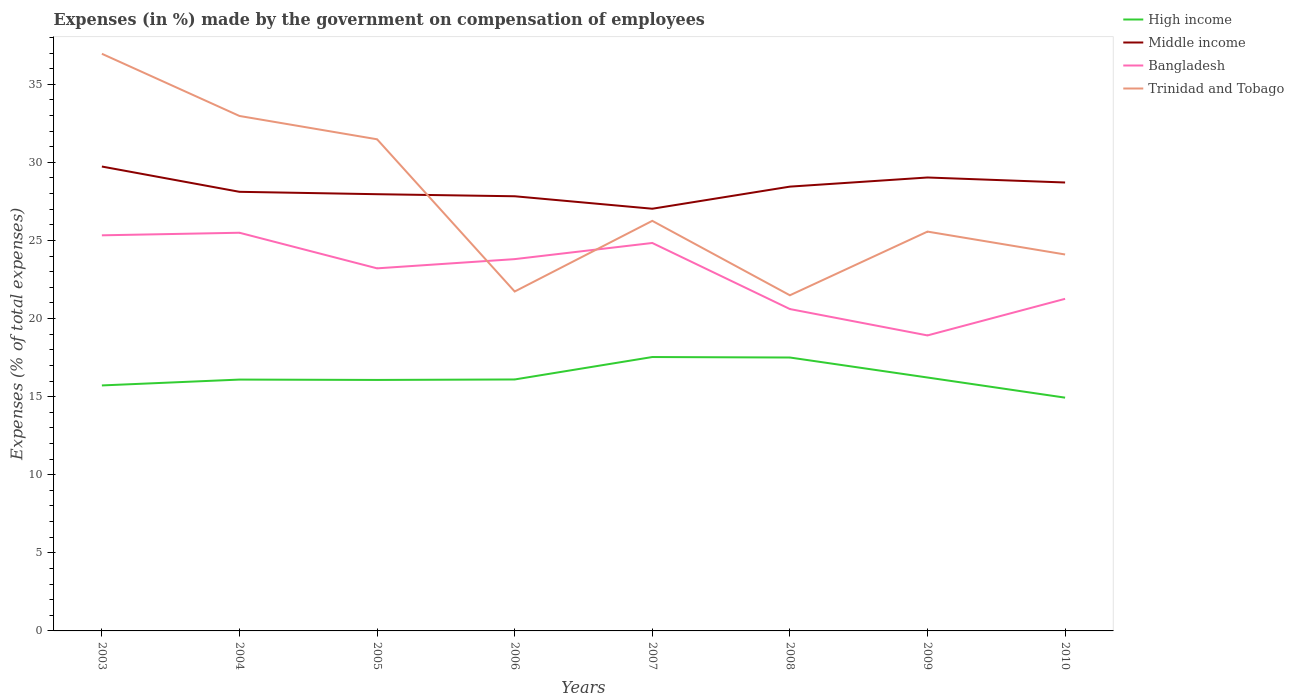Does the line corresponding to High income intersect with the line corresponding to Middle income?
Your answer should be very brief. No. Is the number of lines equal to the number of legend labels?
Ensure brevity in your answer.  Yes. Across all years, what is the maximum percentage of expenses made by the government on compensation of employees in Bangladesh?
Your response must be concise. 18.92. In which year was the percentage of expenses made by the government on compensation of employees in Middle income maximum?
Provide a short and direct response. 2007. What is the total percentage of expenses made by the government on compensation of employees in Bangladesh in the graph?
Offer a very short reply. 3.58. What is the difference between the highest and the second highest percentage of expenses made by the government on compensation of employees in Bangladesh?
Ensure brevity in your answer.  6.57. What is the difference between the highest and the lowest percentage of expenses made by the government on compensation of employees in Trinidad and Tobago?
Offer a very short reply. 3. Is the percentage of expenses made by the government on compensation of employees in Bangladesh strictly greater than the percentage of expenses made by the government on compensation of employees in Middle income over the years?
Your response must be concise. Yes. How many years are there in the graph?
Your answer should be compact. 8. Where does the legend appear in the graph?
Offer a very short reply. Top right. How are the legend labels stacked?
Offer a very short reply. Vertical. What is the title of the graph?
Provide a short and direct response. Expenses (in %) made by the government on compensation of employees. What is the label or title of the Y-axis?
Your answer should be very brief. Expenses (% of total expenses). What is the Expenses (% of total expenses) of High income in 2003?
Ensure brevity in your answer.  15.72. What is the Expenses (% of total expenses) of Middle income in 2003?
Keep it short and to the point. 29.73. What is the Expenses (% of total expenses) of Bangladesh in 2003?
Your response must be concise. 25.33. What is the Expenses (% of total expenses) in Trinidad and Tobago in 2003?
Keep it short and to the point. 36.95. What is the Expenses (% of total expenses) in High income in 2004?
Provide a succinct answer. 16.09. What is the Expenses (% of total expenses) in Middle income in 2004?
Your answer should be very brief. 28.12. What is the Expenses (% of total expenses) of Bangladesh in 2004?
Make the answer very short. 25.49. What is the Expenses (% of total expenses) in Trinidad and Tobago in 2004?
Offer a very short reply. 32.97. What is the Expenses (% of total expenses) in High income in 2005?
Keep it short and to the point. 16.07. What is the Expenses (% of total expenses) in Middle income in 2005?
Provide a succinct answer. 27.96. What is the Expenses (% of total expenses) of Bangladesh in 2005?
Ensure brevity in your answer.  23.21. What is the Expenses (% of total expenses) in Trinidad and Tobago in 2005?
Give a very brief answer. 31.48. What is the Expenses (% of total expenses) of High income in 2006?
Offer a very short reply. 16.1. What is the Expenses (% of total expenses) in Middle income in 2006?
Offer a terse response. 27.83. What is the Expenses (% of total expenses) of Bangladesh in 2006?
Provide a short and direct response. 23.81. What is the Expenses (% of total expenses) of Trinidad and Tobago in 2006?
Provide a succinct answer. 21.73. What is the Expenses (% of total expenses) in High income in 2007?
Your response must be concise. 17.54. What is the Expenses (% of total expenses) in Middle income in 2007?
Your response must be concise. 27.03. What is the Expenses (% of total expenses) of Bangladesh in 2007?
Ensure brevity in your answer.  24.84. What is the Expenses (% of total expenses) in Trinidad and Tobago in 2007?
Your answer should be very brief. 26.26. What is the Expenses (% of total expenses) of High income in 2008?
Keep it short and to the point. 17.51. What is the Expenses (% of total expenses) of Middle income in 2008?
Give a very brief answer. 28.45. What is the Expenses (% of total expenses) of Bangladesh in 2008?
Ensure brevity in your answer.  20.61. What is the Expenses (% of total expenses) in Trinidad and Tobago in 2008?
Keep it short and to the point. 21.49. What is the Expenses (% of total expenses) in High income in 2009?
Keep it short and to the point. 16.23. What is the Expenses (% of total expenses) in Middle income in 2009?
Ensure brevity in your answer.  29.03. What is the Expenses (% of total expenses) in Bangladesh in 2009?
Offer a very short reply. 18.92. What is the Expenses (% of total expenses) in Trinidad and Tobago in 2009?
Ensure brevity in your answer.  25.57. What is the Expenses (% of total expenses) in High income in 2010?
Your answer should be compact. 14.94. What is the Expenses (% of total expenses) of Middle income in 2010?
Your response must be concise. 28.71. What is the Expenses (% of total expenses) of Bangladesh in 2010?
Keep it short and to the point. 21.26. What is the Expenses (% of total expenses) in Trinidad and Tobago in 2010?
Make the answer very short. 24.1. Across all years, what is the maximum Expenses (% of total expenses) of High income?
Offer a terse response. 17.54. Across all years, what is the maximum Expenses (% of total expenses) of Middle income?
Your answer should be very brief. 29.73. Across all years, what is the maximum Expenses (% of total expenses) of Bangladesh?
Provide a short and direct response. 25.49. Across all years, what is the maximum Expenses (% of total expenses) in Trinidad and Tobago?
Offer a terse response. 36.95. Across all years, what is the minimum Expenses (% of total expenses) in High income?
Keep it short and to the point. 14.94. Across all years, what is the minimum Expenses (% of total expenses) of Middle income?
Your response must be concise. 27.03. Across all years, what is the minimum Expenses (% of total expenses) of Bangladesh?
Ensure brevity in your answer.  18.92. Across all years, what is the minimum Expenses (% of total expenses) of Trinidad and Tobago?
Give a very brief answer. 21.49. What is the total Expenses (% of total expenses) of High income in the graph?
Offer a very short reply. 130.18. What is the total Expenses (% of total expenses) in Middle income in the graph?
Provide a succinct answer. 226.86. What is the total Expenses (% of total expenses) in Bangladesh in the graph?
Make the answer very short. 183.47. What is the total Expenses (% of total expenses) in Trinidad and Tobago in the graph?
Ensure brevity in your answer.  220.55. What is the difference between the Expenses (% of total expenses) in High income in 2003 and that in 2004?
Your answer should be very brief. -0.37. What is the difference between the Expenses (% of total expenses) of Middle income in 2003 and that in 2004?
Give a very brief answer. 1.62. What is the difference between the Expenses (% of total expenses) of Bangladesh in 2003 and that in 2004?
Offer a terse response. -0.16. What is the difference between the Expenses (% of total expenses) in Trinidad and Tobago in 2003 and that in 2004?
Offer a very short reply. 3.98. What is the difference between the Expenses (% of total expenses) in High income in 2003 and that in 2005?
Your answer should be compact. -0.35. What is the difference between the Expenses (% of total expenses) of Middle income in 2003 and that in 2005?
Your answer should be compact. 1.77. What is the difference between the Expenses (% of total expenses) in Bangladesh in 2003 and that in 2005?
Offer a terse response. 2.12. What is the difference between the Expenses (% of total expenses) in Trinidad and Tobago in 2003 and that in 2005?
Make the answer very short. 5.48. What is the difference between the Expenses (% of total expenses) in High income in 2003 and that in 2006?
Ensure brevity in your answer.  -0.38. What is the difference between the Expenses (% of total expenses) of Middle income in 2003 and that in 2006?
Ensure brevity in your answer.  1.9. What is the difference between the Expenses (% of total expenses) in Bangladesh in 2003 and that in 2006?
Your answer should be compact. 1.52. What is the difference between the Expenses (% of total expenses) in Trinidad and Tobago in 2003 and that in 2006?
Offer a very short reply. 15.22. What is the difference between the Expenses (% of total expenses) in High income in 2003 and that in 2007?
Your response must be concise. -1.82. What is the difference between the Expenses (% of total expenses) in Middle income in 2003 and that in 2007?
Give a very brief answer. 2.7. What is the difference between the Expenses (% of total expenses) in Bangladesh in 2003 and that in 2007?
Make the answer very short. 0.49. What is the difference between the Expenses (% of total expenses) of Trinidad and Tobago in 2003 and that in 2007?
Your answer should be very brief. 10.7. What is the difference between the Expenses (% of total expenses) of High income in 2003 and that in 2008?
Your response must be concise. -1.79. What is the difference between the Expenses (% of total expenses) in Middle income in 2003 and that in 2008?
Give a very brief answer. 1.29. What is the difference between the Expenses (% of total expenses) of Bangladesh in 2003 and that in 2008?
Your response must be concise. 4.72. What is the difference between the Expenses (% of total expenses) in Trinidad and Tobago in 2003 and that in 2008?
Provide a short and direct response. 15.46. What is the difference between the Expenses (% of total expenses) of High income in 2003 and that in 2009?
Provide a short and direct response. -0.51. What is the difference between the Expenses (% of total expenses) of Middle income in 2003 and that in 2009?
Offer a terse response. 0.7. What is the difference between the Expenses (% of total expenses) in Bangladesh in 2003 and that in 2009?
Your answer should be compact. 6.41. What is the difference between the Expenses (% of total expenses) in Trinidad and Tobago in 2003 and that in 2009?
Your answer should be compact. 11.39. What is the difference between the Expenses (% of total expenses) in High income in 2003 and that in 2010?
Your answer should be very brief. 0.78. What is the difference between the Expenses (% of total expenses) of Middle income in 2003 and that in 2010?
Provide a succinct answer. 1.02. What is the difference between the Expenses (% of total expenses) in Bangladesh in 2003 and that in 2010?
Make the answer very short. 4.07. What is the difference between the Expenses (% of total expenses) in Trinidad and Tobago in 2003 and that in 2010?
Your response must be concise. 12.85. What is the difference between the Expenses (% of total expenses) of High income in 2004 and that in 2005?
Your response must be concise. 0.02. What is the difference between the Expenses (% of total expenses) of Middle income in 2004 and that in 2005?
Make the answer very short. 0.15. What is the difference between the Expenses (% of total expenses) of Bangladesh in 2004 and that in 2005?
Your answer should be compact. 2.28. What is the difference between the Expenses (% of total expenses) of Trinidad and Tobago in 2004 and that in 2005?
Your response must be concise. 1.49. What is the difference between the Expenses (% of total expenses) in High income in 2004 and that in 2006?
Your answer should be very brief. -0.01. What is the difference between the Expenses (% of total expenses) in Middle income in 2004 and that in 2006?
Your response must be concise. 0.28. What is the difference between the Expenses (% of total expenses) of Bangladesh in 2004 and that in 2006?
Provide a short and direct response. 1.69. What is the difference between the Expenses (% of total expenses) of Trinidad and Tobago in 2004 and that in 2006?
Keep it short and to the point. 11.24. What is the difference between the Expenses (% of total expenses) of High income in 2004 and that in 2007?
Your answer should be compact. -1.44. What is the difference between the Expenses (% of total expenses) of Middle income in 2004 and that in 2007?
Provide a succinct answer. 1.08. What is the difference between the Expenses (% of total expenses) in Bangladesh in 2004 and that in 2007?
Offer a terse response. 0.66. What is the difference between the Expenses (% of total expenses) of Trinidad and Tobago in 2004 and that in 2007?
Your response must be concise. 6.71. What is the difference between the Expenses (% of total expenses) of High income in 2004 and that in 2008?
Ensure brevity in your answer.  -1.41. What is the difference between the Expenses (% of total expenses) of Middle income in 2004 and that in 2008?
Provide a succinct answer. -0.33. What is the difference between the Expenses (% of total expenses) in Bangladesh in 2004 and that in 2008?
Keep it short and to the point. 4.89. What is the difference between the Expenses (% of total expenses) in Trinidad and Tobago in 2004 and that in 2008?
Make the answer very short. 11.48. What is the difference between the Expenses (% of total expenses) of High income in 2004 and that in 2009?
Offer a terse response. -0.13. What is the difference between the Expenses (% of total expenses) of Middle income in 2004 and that in 2009?
Your response must be concise. -0.92. What is the difference between the Expenses (% of total expenses) in Bangladesh in 2004 and that in 2009?
Your answer should be very brief. 6.57. What is the difference between the Expenses (% of total expenses) of Trinidad and Tobago in 2004 and that in 2009?
Keep it short and to the point. 7.4. What is the difference between the Expenses (% of total expenses) of High income in 2004 and that in 2010?
Offer a very short reply. 1.16. What is the difference between the Expenses (% of total expenses) of Middle income in 2004 and that in 2010?
Make the answer very short. -0.6. What is the difference between the Expenses (% of total expenses) of Bangladesh in 2004 and that in 2010?
Give a very brief answer. 4.23. What is the difference between the Expenses (% of total expenses) in Trinidad and Tobago in 2004 and that in 2010?
Provide a succinct answer. 8.87. What is the difference between the Expenses (% of total expenses) in High income in 2005 and that in 2006?
Provide a succinct answer. -0.03. What is the difference between the Expenses (% of total expenses) in Middle income in 2005 and that in 2006?
Your answer should be compact. 0.13. What is the difference between the Expenses (% of total expenses) in Bangladesh in 2005 and that in 2006?
Provide a succinct answer. -0.59. What is the difference between the Expenses (% of total expenses) of Trinidad and Tobago in 2005 and that in 2006?
Give a very brief answer. 9.75. What is the difference between the Expenses (% of total expenses) in High income in 2005 and that in 2007?
Your response must be concise. -1.47. What is the difference between the Expenses (% of total expenses) in Middle income in 2005 and that in 2007?
Offer a very short reply. 0.93. What is the difference between the Expenses (% of total expenses) of Bangladesh in 2005 and that in 2007?
Provide a short and direct response. -1.62. What is the difference between the Expenses (% of total expenses) of Trinidad and Tobago in 2005 and that in 2007?
Make the answer very short. 5.22. What is the difference between the Expenses (% of total expenses) of High income in 2005 and that in 2008?
Provide a short and direct response. -1.44. What is the difference between the Expenses (% of total expenses) of Middle income in 2005 and that in 2008?
Your response must be concise. -0.49. What is the difference between the Expenses (% of total expenses) of Bangladesh in 2005 and that in 2008?
Offer a very short reply. 2.61. What is the difference between the Expenses (% of total expenses) of Trinidad and Tobago in 2005 and that in 2008?
Provide a short and direct response. 9.99. What is the difference between the Expenses (% of total expenses) of High income in 2005 and that in 2009?
Your answer should be very brief. -0.16. What is the difference between the Expenses (% of total expenses) in Middle income in 2005 and that in 2009?
Offer a terse response. -1.07. What is the difference between the Expenses (% of total expenses) of Bangladesh in 2005 and that in 2009?
Give a very brief answer. 4.29. What is the difference between the Expenses (% of total expenses) in Trinidad and Tobago in 2005 and that in 2009?
Offer a very short reply. 5.91. What is the difference between the Expenses (% of total expenses) in High income in 2005 and that in 2010?
Your answer should be compact. 1.13. What is the difference between the Expenses (% of total expenses) in Middle income in 2005 and that in 2010?
Offer a terse response. -0.75. What is the difference between the Expenses (% of total expenses) in Bangladesh in 2005 and that in 2010?
Your answer should be compact. 1.95. What is the difference between the Expenses (% of total expenses) of Trinidad and Tobago in 2005 and that in 2010?
Your answer should be very brief. 7.38. What is the difference between the Expenses (% of total expenses) of High income in 2006 and that in 2007?
Your answer should be compact. -1.44. What is the difference between the Expenses (% of total expenses) in Middle income in 2006 and that in 2007?
Offer a terse response. 0.8. What is the difference between the Expenses (% of total expenses) of Bangladesh in 2006 and that in 2007?
Give a very brief answer. -1.03. What is the difference between the Expenses (% of total expenses) in Trinidad and Tobago in 2006 and that in 2007?
Provide a short and direct response. -4.53. What is the difference between the Expenses (% of total expenses) in High income in 2006 and that in 2008?
Your response must be concise. -1.41. What is the difference between the Expenses (% of total expenses) in Middle income in 2006 and that in 2008?
Ensure brevity in your answer.  -0.62. What is the difference between the Expenses (% of total expenses) in Bangladesh in 2006 and that in 2008?
Keep it short and to the point. 3.2. What is the difference between the Expenses (% of total expenses) of Trinidad and Tobago in 2006 and that in 2008?
Offer a terse response. 0.24. What is the difference between the Expenses (% of total expenses) of High income in 2006 and that in 2009?
Give a very brief answer. -0.12. What is the difference between the Expenses (% of total expenses) of Middle income in 2006 and that in 2009?
Offer a terse response. -1.2. What is the difference between the Expenses (% of total expenses) in Bangladesh in 2006 and that in 2009?
Ensure brevity in your answer.  4.89. What is the difference between the Expenses (% of total expenses) of Trinidad and Tobago in 2006 and that in 2009?
Make the answer very short. -3.84. What is the difference between the Expenses (% of total expenses) in High income in 2006 and that in 2010?
Ensure brevity in your answer.  1.16. What is the difference between the Expenses (% of total expenses) in Middle income in 2006 and that in 2010?
Keep it short and to the point. -0.88. What is the difference between the Expenses (% of total expenses) of Bangladesh in 2006 and that in 2010?
Your answer should be very brief. 2.54. What is the difference between the Expenses (% of total expenses) in Trinidad and Tobago in 2006 and that in 2010?
Offer a terse response. -2.37. What is the difference between the Expenses (% of total expenses) in High income in 2007 and that in 2008?
Ensure brevity in your answer.  0.03. What is the difference between the Expenses (% of total expenses) in Middle income in 2007 and that in 2008?
Ensure brevity in your answer.  -1.42. What is the difference between the Expenses (% of total expenses) of Bangladesh in 2007 and that in 2008?
Provide a succinct answer. 4.23. What is the difference between the Expenses (% of total expenses) of Trinidad and Tobago in 2007 and that in 2008?
Offer a terse response. 4.77. What is the difference between the Expenses (% of total expenses) in High income in 2007 and that in 2009?
Keep it short and to the point. 1.31. What is the difference between the Expenses (% of total expenses) of Middle income in 2007 and that in 2009?
Ensure brevity in your answer.  -2. What is the difference between the Expenses (% of total expenses) in Bangladesh in 2007 and that in 2009?
Your response must be concise. 5.92. What is the difference between the Expenses (% of total expenses) in Trinidad and Tobago in 2007 and that in 2009?
Your answer should be compact. 0.69. What is the difference between the Expenses (% of total expenses) of High income in 2007 and that in 2010?
Provide a succinct answer. 2.6. What is the difference between the Expenses (% of total expenses) in Middle income in 2007 and that in 2010?
Your answer should be compact. -1.68. What is the difference between the Expenses (% of total expenses) of Bangladesh in 2007 and that in 2010?
Your response must be concise. 3.58. What is the difference between the Expenses (% of total expenses) of Trinidad and Tobago in 2007 and that in 2010?
Ensure brevity in your answer.  2.15. What is the difference between the Expenses (% of total expenses) in High income in 2008 and that in 2009?
Make the answer very short. 1.28. What is the difference between the Expenses (% of total expenses) of Middle income in 2008 and that in 2009?
Offer a terse response. -0.58. What is the difference between the Expenses (% of total expenses) of Bangladesh in 2008 and that in 2009?
Your answer should be compact. 1.69. What is the difference between the Expenses (% of total expenses) in Trinidad and Tobago in 2008 and that in 2009?
Keep it short and to the point. -4.08. What is the difference between the Expenses (% of total expenses) of High income in 2008 and that in 2010?
Offer a terse response. 2.57. What is the difference between the Expenses (% of total expenses) of Middle income in 2008 and that in 2010?
Make the answer very short. -0.26. What is the difference between the Expenses (% of total expenses) in Bangladesh in 2008 and that in 2010?
Offer a terse response. -0.66. What is the difference between the Expenses (% of total expenses) in Trinidad and Tobago in 2008 and that in 2010?
Your response must be concise. -2.61. What is the difference between the Expenses (% of total expenses) in High income in 2009 and that in 2010?
Provide a succinct answer. 1.29. What is the difference between the Expenses (% of total expenses) in Middle income in 2009 and that in 2010?
Give a very brief answer. 0.32. What is the difference between the Expenses (% of total expenses) of Bangladesh in 2009 and that in 2010?
Your response must be concise. -2.34. What is the difference between the Expenses (% of total expenses) in Trinidad and Tobago in 2009 and that in 2010?
Your answer should be compact. 1.47. What is the difference between the Expenses (% of total expenses) of High income in 2003 and the Expenses (% of total expenses) of Middle income in 2004?
Your answer should be compact. -12.4. What is the difference between the Expenses (% of total expenses) of High income in 2003 and the Expenses (% of total expenses) of Bangladesh in 2004?
Offer a terse response. -9.78. What is the difference between the Expenses (% of total expenses) of High income in 2003 and the Expenses (% of total expenses) of Trinidad and Tobago in 2004?
Offer a very short reply. -17.25. What is the difference between the Expenses (% of total expenses) of Middle income in 2003 and the Expenses (% of total expenses) of Bangladesh in 2004?
Offer a terse response. 4.24. What is the difference between the Expenses (% of total expenses) in Middle income in 2003 and the Expenses (% of total expenses) in Trinidad and Tobago in 2004?
Provide a succinct answer. -3.24. What is the difference between the Expenses (% of total expenses) in Bangladesh in 2003 and the Expenses (% of total expenses) in Trinidad and Tobago in 2004?
Offer a terse response. -7.64. What is the difference between the Expenses (% of total expenses) of High income in 2003 and the Expenses (% of total expenses) of Middle income in 2005?
Give a very brief answer. -12.24. What is the difference between the Expenses (% of total expenses) in High income in 2003 and the Expenses (% of total expenses) in Bangladesh in 2005?
Provide a short and direct response. -7.5. What is the difference between the Expenses (% of total expenses) in High income in 2003 and the Expenses (% of total expenses) in Trinidad and Tobago in 2005?
Ensure brevity in your answer.  -15.76. What is the difference between the Expenses (% of total expenses) in Middle income in 2003 and the Expenses (% of total expenses) in Bangladesh in 2005?
Provide a succinct answer. 6.52. What is the difference between the Expenses (% of total expenses) of Middle income in 2003 and the Expenses (% of total expenses) of Trinidad and Tobago in 2005?
Ensure brevity in your answer.  -1.74. What is the difference between the Expenses (% of total expenses) of Bangladesh in 2003 and the Expenses (% of total expenses) of Trinidad and Tobago in 2005?
Provide a short and direct response. -6.15. What is the difference between the Expenses (% of total expenses) in High income in 2003 and the Expenses (% of total expenses) in Middle income in 2006?
Ensure brevity in your answer.  -12.11. What is the difference between the Expenses (% of total expenses) of High income in 2003 and the Expenses (% of total expenses) of Bangladesh in 2006?
Your response must be concise. -8.09. What is the difference between the Expenses (% of total expenses) of High income in 2003 and the Expenses (% of total expenses) of Trinidad and Tobago in 2006?
Give a very brief answer. -6.01. What is the difference between the Expenses (% of total expenses) in Middle income in 2003 and the Expenses (% of total expenses) in Bangladesh in 2006?
Ensure brevity in your answer.  5.93. What is the difference between the Expenses (% of total expenses) of Middle income in 2003 and the Expenses (% of total expenses) of Trinidad and Tobago in 2006?
Provide a succinct answer. 8. What is the difference between the Expenses (% of total expenses) of Bangladesh in 2003 and the Expenses (% of total expenses) of Trinidad and Tobago in 2006?
Your answer should be very brief. 3.6. What is the difference between the Expenses (% of total expenses) of High income in 2003 and the Expenses (% of total expenses) of Middle income in 2007?
Your answer should be compact. -11.31. What is the difference between the Expenses (% of total expenses) in High income in 2003 and the Expenses (% of total expenses) in Bangladesh in 2007?
Make the answer very short. -9.12. What is the difference between the Expenses (% of total expenses) in High income in 2003 and the Expenses (% of total expenses) in Trinidad and Tobago in 2007?
Offer a terse response. -10.54. What is the difference between the Expenses (% of total expenses) in Middle income in 2003 and the Expenses (% of total expenses) in Bangladesh in 2007?
Make the answer very short. 4.89. What is the difference between the Expenses (% of total expenses) in Middle income in 2003 and the Expenses (% of total expenses) in Trinidad and Tobago in 2007?
Keep it short and to the point. 3.48. What is the difference between the Expenses (% of total expenses) in Bangladesh in 2003 and the Expenses (% of total expenses) in Trinidad and Tobago in 2007?
Give a very brief answer. -0.93. What is the difference between the Expenses (% of total expenses) of High income in 2003 and the Expenses (% of total expenses) of Middle income in 2008?
Provide a succinct answer. -12.73. What is the difference between the Expenses (% of total expenses) of High income in 2003 and the Expenses (% of total expenses) of Bangladesh in 2008?
Give a very brief answer. -4.89. What is the difference between the Expenses (% of total expenses) in High income in 2003 and the Expenses (% of total expenses) in Trinidad and Tobago in 2008?
Provide a short and direct response. -5.77. What is the difference between the Expenses (% of total expenses) of Middle income in 2003 and the Expenses (% of total expenses) of Bangladesh in 2008?
Your answer should be very brief. 9.13. What is the difference between the Expenses (% of total expenses) in Middle income in 2003 and the Expenses (% of total expenses) in Trinidad and Tobago in 2008?
Make the answer very short. 8.24. What is the difference between the Expenses (% of total expenses) of Bangladesh in 2003 and the Expenses (% of total expenses) of Trinidad and Tobago in 2008?
Offer a terse response. 3.84. What is the difference between the Expenses (% of total expenses) in High income in 2003 and the Expenses (% of total expenses) in Middle income in 2009?
Ensure brevity in your answer.  -13.31. What is the difference between the Expenses (% of total expenses) in High income in 2003 and the Expenses (% of total expenses) in Bangladesh in 2009?
Your response must be concise. -3.2. What is the difference between the Expenses (% of total expenses) of High income in 2003 and the Expenses (% of total expenses) of Trinidad and Tobago in 2009?
Make the answer very short. -9.85. What is the difference between the Expenses (% of total expenses) of Middle income in 2003 and the Expenses (% of total expenses) of Bangladesh in 2009?
Provide a succinct answer. 10.81. What is the difference between the Expenses (% of total expenses) of Middle income in 2003 and the Expenses (% of total expenses) of Trinidad and Tobago in 2009?
Give a very brief answer. 4.17. What is the difference between the Expenses (% of total expenses) in Bangladesh in 2003 and the Expenses (% of total expenses) in Trinidad and Tobago in 2009?
Provide a succinct answer. -0.24. What is the difference between the Expenses (% of total expenses) in High income in 2003 and the Expenses (% of total expenses) in Middle income in 2010?
Your answer should be very brief. -12.99. What is the difference between the Expenses (% of total expenses) in High income in 2003 and the Expenses (% of total expenses) in Bangladesh in 2010?
Offer a terse response. -5.55. What is the difference between the Expenses (% of total expenses) of High income in 2003 and the Expenses (% of total expenses) of Trinidad and Tobago in 2010?
Offer a terse response. -8.38. What is the difference between the Expenses (% of total expenses) in Middle income in 2003 and the Expenses (% of total expenses) in Bangladesh in 2010?
Your response must be concise. 8.47. What is the difference between the Expenses (% of total expenses) of Middle income in 2003 and the Expenses (% of total expenses) of Trinidad and Tobago in 2010?
Offer a terse response. 5.63. What is the difference between the Expenses (% of total expenses) of Bangladesh in 2003 and the Expenses (% of total expenses) of Trinidad and Tobago in 2010?
Your response must be concise. 1.23. What is the difference between the Expenses (% of total expenses) of High income in 2004 and the Expenses (% of total expenses) of Middle income in 2005?
Your response must be concise. -11.87. What is the difference between the Expenses (% of total expenses) in High income in 2004 and the Expenses (% of total expenses) in Bangladesh in 2005?
Make the answer very short. -7.12. What is the difference between the Expenses (% of total expenses) in High income in 2004 and the Expenses (% of total expenses) in Trinidad and Tobago in 2005?
Make the answer very short. -15.39. What is the difference between the Expenses (% of total expenses) in Middle income in 2004 and the Expenses (% of total expenses) in Bangladesh in 2005?
Offer a very short reply. 4.9. What is the difference between the Expenses (% of total expenses) in Middle income in 2004 and the Expenses (% of total expenses) in Trinidad and Tobago in 2005?
Your response must be concise. -3.36. What is the difference between the Expenses (% of total expenses) of Bangladesh in 2004 and the Expenses (% of total expenses) of Trinidad and Tobago in 2005?
Your answer should be compact. -5.98. What is the difference between the Expenses (% of total expenses) of High income in 2004 and the Expenses (% of total expenses) of Middle income in 2006?
Offer a terse response. -11.74. What is the difference between the Expenses (% of total expenses) of High income in 2004 and the Expenses (% of total expenses) of Bangladesh in 2006?
Your answer should be compact. -7.71. What is the difference between the Expenses (% of total expenses) in High income in 2004 and the Expenses (% of total expenses) in Trinidad and Tobago in 2006?
Give a very brief answer. -5.64. What is the difference between the Expenses (% of total expenses) in Middle income in 2004 and the Expenses (% of total expenses) in Bangladesh in 2006?
Your answer should be very brief. 4.31. What is the difference between the Expenses (% of total expenses) in Middle income in 2004 and the Expenses (% of total expenses) in Trinidad and Tobago in 2006?
Keep it short and to the point. 6.38. What is the difference between the Expenses (% of total expenses) in Bangladesh in 2004 and the Expenses (% of total expenses) in Trinidad and Tobago in 2006?
Make the answer very short. 3.76. What is the difference between the Expenses (% of total expenses) in High income in 2004 and the Expenses (% of total expenses) in Middle income in 2007?
Make the answer very short. -10.94. What is the difference between the Expenses (% of total expenses) of High income in 2004 and the Expenses (% of total expenses) of Bangladesh in 2007?
Your answer should be very brief. -8.75. What is the difference between the Expenses (% of total expenses) of High income in 2004 and the Expenses (% of total expenses) of Trinidad and Tobago in 2007?
Provide a succinct answer. -10.16. What is the difference between the Expenses (% of total expenses) of Middle income in 2004 and the Expenses (% of total expenses) of Bangladesh in 2007?
Offer a very short reply. 3.28. What is the difference between the Expenses (% of total expenses) of Middle income in 2004 and the Expenses (% of total expenses) of Trinidad and Tobago in 2007?
Make the answer very short. 1.86. What is the difference between the Expenses (% of total expenses) in Bangladesh in 2004 and the Expenses (% of total expenses) in Trinidad and Tobago in 2007?
Keep it short and to the point. -0.76. What is the difference between the Expenses (% of total expenses) of High income in 2004 and the Expenses (% of total expenses) of Middle income in 2008?
Your answer should be very brief. -12.35. What is the difference between the Expenses (% of total expenses) in High income in 2004 and the Expenses (% of total expenses) in Bangladesh in 2008?
Give a very brief answer. -4.52. What is the difference between the Expenses (% of total expenses) of High income in 2004 and the Expenses (% of total expenses) of Trinidad and Tobago in 2008?
Provide a succinct answer. -5.4. What is the difference between the Expenses (% of total expenses) in Middle income in 2004 and the Expenses (% of total expenses) in Bangladesh in 2008?
Provide a short and direct response. 7.51. What is the difference between the Expenses (% of total expenses) in Middle income in 2004 and the Expenses (% of total expenses) in Trinidad and Tobago in 2008?
Provide a short and direct response. 6.63. What is the difference between the Expenses (% of total expenses) in Bangladesh in 2004 and the Expenses (% of total expenses) in Trinidad and Tobago in 2008?
Your answer should be compact. 4. What is the difference between the Expenses (% of total expenses) in High income in 2004 and the Expenses (% of total expenses) in Middle income in 2009?
Your answer should be very brief. -12.94. What is the difference between the Expenses (% of total expenses) of High income in 2004 and the Expenses (% of total expenses) of Bangladesh in 2009?
Offer a terse response. -2.83. What is the difference between the Expenses (% of total expenses) of High income in 2004 and the Expenses (% of total expenses) of Trinidad and Tobago in 2009?
Make the answer very short. -9.47. What is the difference between the Expenses (% of total expenses) of Middle income in 2004 and the Expenses (% of total expenses) of Bangladesh in 2009?
Keep it short and to the point. 9.2. What is the difference between the Expenses (% of total expenses) in Middle income in 2004 and the Expenses (% of total expenses) in Trinidad and Tobago in 2009?
Your response must be concise. 2.55. What is the difference between the Expenses (% of total expenses) of Bangladesh in 2004 and the Expenses (% of total expenses) of Trinidad and Tobago in 2009?
Ensure brevity in your answer.  -0.07. What is the difference between the Expenses (% of total expenses) in High income in 2004 and the Expenses (% of total expenses) in Middle income in 2010?
Your answer should be compact. -12.62. What is the difference between the Expenses (% of total expenses) of High income in 2004 and the Expenses (% of total expenses) of Bangladesh in 2010?
Your response must be concise. -5.17. What is the difference between the Expenses (% of total expenses) of High income in 2004 and the Expenses (% of total expenses) of Trinidad and Tobago in 2010?
Provide a succinct answer. -8.01. What is the difference between the Expenses (% of total expenses) in Middle income in 2004 and the Expenses (% of total expenses) in Bangladesh in 2010?
Your answer should be compact. 6.85. What is the difference between the Expenses (% of total expenses) in Middle income in 2004 and the Expenses (% of total expenses) in Trinidad and Tobago in 2010?
Your response must be concise. 4.01. What is the difference between the Expenses (% of total expenses) in Bangladesh in 2004 and the Expenses (% of total expenses) in Trinidad and Tobago in 2010?
Keep it short and to the point. 1.39. What is the difference between the Expenses (% of total expenses) in High income in 2005 and the Expenses (% of total expenses) in Middle income in 2006?
Make the answer very short. -11.76. What is the difference between the Expenses (% of total expenses) in High income in 2005 and the Expenses (% of total expenses) in Bangladesh in 2006?
Give a very brief answer. -7.74. What is the difference between the Expenses (% of total expenses) in High income in 2005 and the Expenses (% of total expenses) in Trinidad and Tobago in 2006?
Keep it short and to the point. -5.66. What is the difference between the Expenses (% of total expenses) in Middle income in 2005 and the Expenses (% of total expenses) in Bangladesh in 2006?
Keep it short and to the point. 4.16. What is the difference between the Expenses (% of total expenses) of Middle income in 2005 and the Expenses (% of total expenses) of Trinidad and Tobago in 2006?
Offer a very short reply. 6.23. What is the difference between the Expenses (% of total expenses) of Bangladesh in 2005 and the Expenses (% of total expenses) of Trinidad and Tobago in 2006?
Provide a short and direct response. 1.48. What is the difference between the Expenses (% of total expenses) in High income in 2005 and the Expenses (% of total expenses) in Middle income in 2007?
Give a very brief answer. -10.96. What is the difference between the Expenses (% of total expenses) in High income in 2005 and the Expenses (% of total expenses) in Bangladesh in 2007?
Your answer should be compact. -8.77. What is the difference between the Expenses (% of total expenses) in High income in 2005 and the Expenses (% of total expenses) in Trinidad and Tobago in 2007?
Offer a terse response. -10.19. What is the difference between the Expenses (% of total expenses) of Middle income in 2005 and the Expenses (% of total expenses) of Bangladesh in 2007?
Provide a short and direct response. 3.12. What is the difference between the Expenses (% of total expenses) in Middle income in 2005 and the Expenses (% of total expenses) in Trinidad and Tobago in 2007?
Offer a very short reply. 1.71. What is the difference between the Expenses (% of total expenses) in Bangladesh in 2005 and the Expenses (% of total expenses) in Trinidad and Tobago in 2007?
Your answer should be compact. -3.04. What is the difference between the Expenses (% of total expenses) of High income in 2005 and the Expenses (% of total expenses) of Middle income in 2008?
Your response must be concise. -12.38. What is the difference between the Expenses (% of total expenses) of High income in 2005 and the Expenses (% of total expenses) of Bangladesh in 2008?
Offer a terse response. -4.54. What is the difference between the Expenses (% of total expenses) of High income in 2005 and the Expenses (% of total expenses) of Trinidad and Tobago in 2008?
Ensure brevity in your answer.  -5.42. What is the difference between the Expenses (% of total expenses) of Middle income in 2005 and the Expenses (% of total expenses) of Bangladesh in 2008?
Your answer should be compact. 7.35. What is the difference between the Expenses (% of total expenses) of Middle income in 2005 and the Expenses (% of total expenses) of Trinidad and Tobago in 2008?
Your response must be concise. 6.47. What is the difference between the Expenses (% of total expenses) of Bangladesh in 2005 and the Expenses (% of total expenses) of Trinidad and Tobago in 2008?
Your answer should be compact. 1.72. What is the difference between the Expenses (% of total expenses) of High income in 2005 and the Expenses (% of total expenses) of Middle income in 2009?
Your answer should be very brief. -12.96. What is the difference between the Expenses (% of total expenses) in High income in 2005 and the Expenses (% of total expenses) in Bangladesh in 2009?
Provide a short and direct response. -2.85. What is the difference between the Expenses (% of total expenses) in High income in 2005 and the Expenses (% of total expenses) in Trinidad and Tobago in 2009?
Ensure brevity in your answer.  -9.5. What is the difference between the Expenses (% of total expenses) of Middle income in 2005 and the Expenses (% of total expenses) of Bangladesh in 2009?
Your answer should be very brief. 9.04. What is the difference between the Expenses (% of total expenses) in Middle income in 2005 and the Expenses (% of total expenses) in Trinidad and Tobago in 2009?
Make the answer very short. 2.39. What is the difference between the Expenses (% of total expenses) of Bangladesh in 2005 and the Expenses (% of total expenses) of Trinidad and Tobago in 2009?
Offer a terse response. -2.35. What is the difference between the Expenses (% of total expenses) in High income in 2005 and the Expenses (% of total expenses) in Middle income in 2010?
Keep it short and to the point. -12.64. What is the difference between the Expenses (% of total expenses) in High income in 2005 and the Expenses (% of total expenses) in Bangladesh in 2010?
Offer a terse response. -5.19. What is the difference between the Expenses (% of total expenses) in High income in 2005 and the Expenses (% of total expenses) in Trinidad and Tobago in 2010?
Give a very brief answer. -8.03. What is the difference between the Expenses (% of total expenses) in Middle income in 2005 and the Expenses (% of total expenses) in Bangladesh in 2010?
Ensure brevity in your answer.  6.7. What is the difference between the Expenses (% of total expenses) of Middle income in 2005 and the Expenses (% of total expenses) of Trinidad and Tobago in 2010?
Provide a short and direct response. 3.86. What is the difference between the Expenses (% of total expenses) of Bangladesh in 2005 and the Expenses (% of total expenses) of Trinidad and Tobago in 2010?
Your response must be concise. -0.89. What is the difference between the Expenses (% of total expenses) of High income in 2006 and the Expenses (% of total expenses) of Middle income in 2007?
Your answer should be very brief. -10.93. What is the difference between the Expenses (% of total expenses) of High income in 2006 and the Expenses (% of total expenses) of Bangladesh in 2007?
Offer a very short reply. -8.74. What is the difference between the Expenses (% of total expenses) in High income in 2006 and the Expenses (% of total expenses) in Trinidad and Tobago in 2007?
Offer a very short reply. -10.16. What is the difference between the Expenses (% of total expenses) in Middle income in 2006 and the Expenses (% of total expenses) in Bangladesh in 2007?
Provide a succinct answer. 2.99. What is the difference between the Expenses (% of total expenses) of Middle income in 2006 and the Expenses (% of total expenses) of Trinidad and Tobago in 2007?
Make the answer very short. 1.57. What is the difference between the Expenses (% of total expenses) in Bangladesh in 2006 and the Expenses (% of total expenses) in Trinidad and Tobago in 2007?
Your answer should be very brief. -2.45. What is the difference between the Expenses (% of total expenses) in High income in 2006 and the Expenses (% of total expenses) in Middle income in 2008?
Provide a succinct answer. -12.35. What is the difference between the Expenses (% of total expenses) of High income in 2006 and the Expenses (% of total expenses) of Bangladesh in 2008?
Ensure brevity in your answer.  -4.51. What is the difference between the Expenses (% of total expenses) in High income in 2006 and the Expenses (% of total expenses) in Trinidad and Tobago in 2008?
Offer a very short reply. -5.39. What is the difference between the Expenses (% of total expenses) in Middle income in 2006 and the Expenses (% of total expenses) in Bangladesh in 2008?
Make the answer very short. 7.22. What is the difference between the Expenses (% of total expenses) of Middle income in 2006 and the Expenses (% of total expenses) of Trinidad and Tobago in 2008?
Keep it short and to the point. 6.34. What is the difference between the Expenses (% of total expenses) in Bangladesh in 2006 and the Expenses (% of total expenses) in Trinidad and Tobago in 2008?
Provide a short and direct response. 2.32. What is the difference between the Expenses (% of total expenses) of High income in 2006 and the Expenses (% of total expenses) of Middle income in 2009?
Offer a terse response. -12.93. What is the difference between the Expenses (% of total expenses) in High income in 2006 and the Expenses (% of total expenses) in Bangladesh in 2009?
Give a very brief answer. -2.82. What is the difference between the Expenses (% of total expenses) in High income in 2006 and the Expenses (% of total expenses) in Trinidad and Tobago in 2009?
Offer a terse response. -9.47. What is the difference between the Expenses (% of total expenses) of Middle income in 2006 and the Expenses (% of total expenses) of Bangladesh in 2009?
Provide a succinct answer. 8.91. What is the difference between the Expenses (% of total expenses) in Middle income in 2006 and the Expenses (% of total expenses) in Trinidad and Tobago in 2009?
Offer a terse response. 2.26. What is the difference between the Expenses (% of total expenses) in Bangladesh in 2006 and the Expenses (% of total expenses) in Trinidad and Tobago in 2009?
Keep it short and to the point. -1.76. What is the difference between the Expenses (% of total expenses) in High income in 2006 and the Expenses (% of total expenses) in Middle income in 2010?
Offer a terse response. -12.61. What is the difference between the Expenses (% of total expenses) of High income in 2006 and the Expenses (% of total expenses) of Bangladesh in 2010?
Your response must be concise. -5.16. What is the difference between the Expenses (% of total expenses) in High income in 2006 and the Expenses (% of total expenses) in Trinidad and Tobago in 2010?
Give a very brief answer. -8. What is the difference between the Expenses (% of total expenses) of Middle income in 2006 and the Expenses (% of total expenses) of Bangladesh in 2010?
Keep it short and to the point. 6.57. What is the difference between the Expenses (% of total expenses) in Middle income in 2006 and the Expenses (% of total expenses) in Trinidad and Tobago in 2010?
Your response must be concise. 3.73. What is the difference between the Expenses (% of total expenses) in Bangladesh in 2006 and the Expenses (% of total expenses) in Trinidad and Tobago in 2010?
Your answer should be compact. -0.3. What is the difference between the Expenses (% of total expenses) of High income in 2007 and the Expenses (% of total expenses) of Middle income in 2008?
Your response must be concise. -10.91. What is the difference between the Expenses (% of total expenses) of High income in 2007 and the Expenses (% of total expenses) of Bangladesh in 2008?
Provide a succinct answer. -3.07. What is the difference between the Expenses (% of total expenses) in High income in 2007 and the Expenses (% of total expenses) in Trinidad and Tobago in 2008?
Give a very brief answer. -3.95. What is the difference between the Expenses (% of total expenses) of Middle income in 2007 and the Expenses (% of total expenses) of Bangladesh in 2008?
Your response must be concise. 6.42. What is the difference between the Expenses (% of total expenses) in Middle income in 2007 and the Expenses (% of total expenses) in Trinidad and Tobago in 2008?
Provide a succinct answer. 5.54. What is the difference between the Expenses (% of total expenses) of Bangladesh in 2007 and the Expenses (% of total expenses) of Trinidad and Tobago in 2008?
Make the answer very short. 3.35. What is the difference between the Expenses (% of total expenses) of High income in 2007 and the Expenses (% of total expenses) of Middle income in 2009?
Offer a very short reply. -11.5. What is the difference between the Expenses (% of total expenses) of High income in 2007 and the Expenses (% of total expenses) of Bangladesh in 2009?
Ensure brevity in your answer.  -1.38. What is the difference between the Expenses (% of total expenses) in High income in 2007 and the Expenses (% of total expenses) in Trinidad and Tobago in 2009?
Give a very brief answer. -8.03. What is the difference between the Expenses (% of total expenses) in Middle income in 2007 and the Expenses (% of total expenses) in Bangladesh in 2009?
Make the answer very short. 8.11. What is the difference between the Expenses (% of total expenses) of Middle income in 2007 and the Expenses (% of total expenses) of Trinidad and Tobago in 2009?
Provide a succinct answer. 1.46. What is the difference between the Expenses (% of total expenses) of Bangladesh in 2007 and the Expenses (% of total expenses) of Trinidad and Tobago in 2009?
Provide a succinct answer. -0.73. What is the difference between the Expenses (% of total expenses) in High income in 2007 and the Expenses (% of total expenses) in Middle income in 2010?
Ensure brevity in your answer.  -11.18. What is the difference between the Expenses (% of total expenses) in High income in 2007 and the Expenses (% of total expenses) in Bangladesh in 2010?
Your answer should be compact. -3.73. What is the difference between the Expenses (% of total expenses) in High income in 2007 and the Expenses (% of total expenses) in Trinidad and Tobago in 2010?
Offer a very short reply. -6.57. What is the difference between the Expenses (% of total expenses) in Middle income in 2007 and the Expenses (% of total expenses) in Bangladesh in 2010?
Give a very brief answer. 5.77. What is the difference between the Expenses (% of total expenses) in Middle income in 2007 and the Expenses (% of total expenses) in Trinidad and Tobago in 2010?
Give a very brief answer. 2.93. What is the difference between the Expenses (% of total expenses) of Bangladesh in 2007 and the Expenses (% of total expenses) of Trinidad and Tobago in 2010?
Your answer should be compact. 0.74. What is the difference between the Expenses (% of total expenses) of High income in 2008 and the Expenses (% of total expenses) of Middle income in 2009?
Your answer should be very brief. -11.53. What is the difference between the Expenses (% of total expenses) of High income in 2008 and the Expenses (% of total expenses) of Bangladesh in 2009?
Your response must be concise. -1.41. What is the difference between the Expenses (% of total expenses) of High income in 2008 and the Expenses (% of total expenses) of Trinidad and Tobago in 2009?
Make the answer very short. -8.06. What is the difference between the Expenses (% of total expenses) in Middle income in 2008 and the Expenses (% of total expenses) in Bangladesh in 2009?
Offer a very short reply. 9.53. What is the difference between the Expenses (% of total expenses) in Middle income in 2008 and the Expenses (% of total expenses) in Trinidad and Tobago in 2009?
Give a very brief answer. 2.88. What is the difference between the Expenses (% of total expenses) in Bangladesh in 2008 and the Expenses (% of total expenses) in Trinidad and Tobago in 2009?
Your answer should be very brief. -4.96. What is the difference between the Expenses (% of total expenses) in High income in 2008 and the Expenses (% of total expenses) in Middle income in 2010?
Provide a short and direct response. -11.21. What is the difference between the Expenses (% of total expenses) of High income in 2008 and the Expenses (% of total expenses) of Bangladesh in 2010?
Offer a terse response. -3.76. What is the difference between the Expenses (% of total expenses) in High income in 2008 and the Expenses (% of total expenses) in Trinidad and Tobago in 2010?
Give a very brief answer. -6.6. What is the difference between the Expenses (% of total expenses) in Middle income in 2008 and the Expenses (% of total expenses) in Bangladesh in 2010?
Give a very brief answer. 7.18. What is the difference between the Expenses (% of total expenses) of Middle income in 2008 and the Expenses (% of total expenses) of Trinidad and Tobago in 2010?
Your answer should be very brief. 4.34. What is the difference between the Expenses (% of total expenses) in Bangladesh in 2008 and the Expenses (% of total expenses) in Trinidad and Tobago in 2010?
Provide a short and direct response. -3.49. What is the difference between the Expenses (% of total expenses) of High income in 2009 and the Expenses (% of total expenses) of Middle income in 2010?
Give a very brief answer. -12.49. What is the difference between the Expenses (% of total expenses) in High income in 2009 and the Expenses (% of total expenses) in Bangladesh in 2010?
Your answer should be very brief. -5.04. What is the difference between the Expenses (% of total expenses) in High income in 2009 and the Expenses (% of total expenses) in Trinidad and Tobago in 2010?
Make the answer very short. -7.88. What is the difference between the Expenses (% of total expenses) of Middle income in 2009 and the Expenses (% of total expenses) of Bangladesh in 2010?
Your answer should be compact. 7.77. What is the difference between the Expenses (% of total expenses) of Middle income in 2009 and the Expenses (% of total expenses) of Trinidad and Tobago in 2010?
Ensure brevity in your answer.  4.93. What is the difference between the Expenses (% of total expenses) in Bangladesh in 2009 and the Expenses (% of total expenses) in Trinidad and Tobago in 2010?
Offer a very short reply. -5.18. What is the average Expenses (% of total expenses) in High income per year?
Provide a succinct answer. 16.27. What is the average Expenses (% of total expenses) in Middle income per year?
Ensure brevity in your answer.  28.36. What is the average Expenses (% of total expenses) of Bangladesh per year?
Provide a short and direct response. 22.93. What is the average Expenses (% of total expenses) in Trinidad and Tobago per year?
Provide a succinct answer. 27.57. In the year 2003, what is the difference between the Expenses (% of total expenses) in High income and Expenses (% of total expenses) in Middle income?
Make the answer very short. -14.02. In the year 2003, what is the difference between the Expenses (% of total expenses) in High income and Expenses (% of total expenses) in Bangladesh?
Provide a succinct answer. -9.61. In the year 2003, what is the difference between the Expenses (% of total expenses) in High income and Expenses (% of total expenses) in Trinidad and Tobago?
Give a very brief answer. -21.24. In the year 2003, what is the difference between the Expenses (% of total expenses) in Middle income and Expenses (% of total expenses) in Bangladesh?
Keep it short and to the point. 4.4. In the year 2003, what is the difference between the Expenses (% of total expenses) in Middle income and Expenses (% of total expenses) in Trinidad and Tobago?
Give a very brief answer. -7.22. In the year 2003, what is the difference between the Expenses (% of total expenses) of Bangladesh and Expenses (% of total expenses) of Trinidad and Tobago?
Make the answer very short. -11.62. In the year 2004, what is the difference between the Expenses (% of total expenses) of High income and Expenses (% of total expenses) of Middle income?
Make the answer very short. -12.02. In the year 2004, what is the difference between the Expenses (% of total expenses) in High income and Expenses (% of total expenses) in Bangladesh?
Your answer should be very brief. -9.4. In the year 2004, what is the difference between the Expenses (% of total expenses) in High income and Expenses (% of total expenses) in Trinidad and Tobago?
Provide a succinct answer. -16.88. In the year 2004, what is the difference between the Expenses (% of total expenses) of Middle income and Expenses (% of total expenses) of Bangladesh?
Offer a very short reply. 2.62. In the year 2004, what is the difference between the Expenses (% of total expenses) in Middle income and Expenses (% of total expenses) in Trinidad and Tobago?
Provide a succinct answer. -4.86. In the year 2004, what is the difference between the Expenses (% of total expenses) in Bangladesh and Expenses (% of total expenses) in Trinidad and Tobago?
Your answer should be compact. -7.48. In the year 2005, what is the difference between the Expenses (% of total expenses) of High income and Expenses (% of total expenses) of Middle income?
Provide a short and direct response. -11.89. In the year 2005, what is the difference between the Expenses (% of total expenses) of High income and Expenses (% of total expenses) of Bangladesh?
Your answer should be very brief. -7.14. In the year 2005, what is the difference between the Expenses (% of total expenses) of High income and Expenses (% of total expenses) of Trinidad and Tobago?
Give a very brief answer. -15.41. In the year 2005, what is the difference between the Expenses (% of total expenses) of Middle income and Expenses (% of total expenses) of Bangladesh?
Make the answer very short. 4.75. In the year 2005, what is the difference between the Expenses (% of total expenses) in Middle income and Expenses (% of total expenses) in Trinidad and Tobago?
Make the answer very short. -3.52. In the year 2005, what is the difference between the Expenses (% of total expenses) in Bangladesh and Expenses (% of total expenses) in Trinidad and Tobago?
Provide a succinct answer. -8.26. In the year 2006, what is the difference between the Expenses (% of total expenses) in High income and Expenses (% of total expenses) in Middle income?
Your response must be concise. -11.73. In the year 2006, what is the difference between the Expenses (% of total expenses) of High income and Expenses (% of total expenses) of Bangladesh?
Provide a succinct answer. -7.71. In the year 2006, what is the difference between the Expenses (% of total expenses) of High income and Expenses (% of total expenses) of Trinidad and Tobago?
Make the answer very short. -5.63. In the year 2006, what is the difference between the Expenses (% of total expenses) in Middle income and Expenses (% of total expenses) in Bangladesh?
Give a very brief answer. 4.03. In the year 2006, what is the difference between the Expenses (% of total expenses) of Middle income and Expenses (% of total expenses) of Trinidad and Tobago?
Your response must be concise. 6.1. In the year 2006, what is the difference between the Expenses (% of total expenses) of Bangladesh and Expenses (% of total expenses) of Trinidad and Tobago?
Give a very brief answer. 2.07. In the year 2007, what is the difference between the Expenses (% of total expenses) of High income and Expenses (% of total expenses) of Middle income?
Keep it short and to the point. -9.5. In the year 2007, what is the difference between the Expenses (% of total expenses) of High income and Expenses (% of total expenses) of Bangladesh?
Your response must be concise. -7.3. In the year 2007, what is the difference between the Expenses (% of total expenses) of High income and Expenses (% of total expenses) of Trinidad and Tobago?
Provide a short and direct response. -8.72. In the year 2007, what is the difference between the Expenses (% of total expenses) of Middle income and Expenses (% of total expenses) of Bangladesh?
Your answer should be very brief. 2.19. In the year 2007, what is the difference between the Expenses (% of total expenses) of Middle income and Expenses (% of total expenses) of Trinidad and Tobago?
Offer a very short reply. 0.78. In the year 2007, what is the difference between the Expenses (% of total expenses) in Bangladesh and Expenses (% of total expenses) in Trinidad and Tobago?
Your answer should be compact. -1.42. In the year 2008, what is the difference between the Expenses (% of total expenses) of High income and Expenses (% of total expenses) of Middle income?
Your answer should be compact. -10.94. In the year 2008, what is the difference between the Expenses (% of total expenses) of High income and Expenses (% of total expenses) of Bangladesh?
Provide a succinct answer. -3.1. In the year 2008, what is the difference between the Expenses (% of total expenses) in High income and Expenses (% of total expenses) in Trinidad and Tobago?
Give a very brief answer. -3.98. In the year 2008, what is the difference between the Expenses (% of total expenses) in Middle income and Expenses (% of total expenses) in Bangladesh?
Offer a very short reply. 7.84. In the year 2008, what is the difference between the Expenses (% of total expenses) in Middle income and Expenses (% of total expenses) in Trinidad and Tobago?
Keep it short and to the point. 6.96. In the year 2008, what is the difference between the Expenses (% of total expenses) of Bangladesh and Expenses (% of total expenses) of Trinidad and Tobago?
Your answer should be compact. -0.88. In the year 2009, what is the difference between the Expenses (% of total expenses) in High income and Expenses (% of total expenses) in Middle income?
Make the answer very short. -12.81. In the year 2009, what is the difference between the Expenses (% of total expenses) in High income and Expenses (% of total expenses) in Bangladesh?
Provide a short and direct response. -2.69. In the year 2009, what is the difference between the Expenses (% of total expenses) in High income and Expenses (% of total expenses) in Trinidad and Tobago?
Offer a very short reply. -9.34. In the year 2009, what is the difference between the Expenses (% of total expenses) in Middle income and Expenses (% of total expenses) in Bangladesh?
Give a very brief answer. 10.11. In the year 2009, what is the difference between the Expenses (% of total expenses) of Middle income and Expenses (% of total expenses) of Trinidad and Tobago?
Give a very brief answer. 3.46. In the year 2009, what is the difference between the Expenses (% of total expenses) in Bangladesh and Expenses (% of total expenses) in Trinidad and Tobago?
Offer a terse response. -6.65. In the year 2010, what is the difference between the Expenses (% of total expenses) of High income and Expenses (% of total expenses) of Middle income?
Ensure brevity in your answer.  -13.78. In the year 2010, what is the difference between the Expenses (% of total expenses) of High income and Expenses (% of total expenses) of Bangladesh?
Give a very brief answer. -6.33. In the year 2010, what is the difference between the Expenses (% of total expenses) of High income and Expenses (% of total expenses) of Trinidad and Tobago?
Ensure brevity in your answer.  -9.17. In the year 2010, what is the difference between the Expenses (% of total expenses) in Middle income and Expenses (% of total expenses) in Bangladesh?
Offer a terse response. 7.45. In the year 2010, what is the difference between the Expenses (% of total expenses) in Middle income and Expenses (% of total expenses) in Trinidad and Tobago?
Make the answer very short. 4.61. In the year 2010, what is the difference between the Expenses (% of total expenses) in Bangladesh and Expenses (% of total expenses) in Trinidad and Tobago?
Provide a short and direct response. -2.84. What is the ratio of the Expenses (% of total expenses) in High income in 2003 to that in 2004?
Keep it short and to the point. 0.98. What is the ratio of the Expenses (% of total expenses) in Middle income in 2003 to that in 2004?
Ensure brevity in your answer.  1.06. What is the ratio of the Expenses (% of total expenses) of Trinidad and Tobago in 2003 to that in 2004?
Ensure brevity in your answer.  1.12. What is the ratio of the Expenses (% of total expenses) of High income in 2003 to that in 2005?
Your answer should be compact. 0.98. What is the ratio of the Expenses (% of total expenses) in Middle income in 2003 to that in 2005?
Your answer should be compact. 1.06. What is the ratio of the Expenses (% of total expenses) in Bangladesh in 2003 to that in 2005?
Provide a short and direct response. 1.09. What is the ratio of the Expenses (% of total expenses) in Trinidad and Tobago in 2003 to that in 2005?
Give a very brief answer. 1.17. What is the ratio of the Expenses (% of total expenses) of High income in 2003 to that in 2006?
Offer a very short reply. 0.98. What is the ratio of the Expenses (% of total expenses) of Middle income in 2003 to that in 2006?
Offer a terse response. 1.07. What is the ratio of the Expenses (% of total expenses) of Bangladesh in 2003 to that in 2006?
Provide a short and direct response. 1.06. What is the ratio of the Expenses (% of total expenses) in Trinidad and Tobago in 2003 to that in 2006?
Your answer should be very brief. 1.7. What is the ratio of the Expenses (% of total expenses) of High income in 2003 to that in 2007?
Your answer should be compact. 0.9. What is the ratio of the Expenses (% of total expenses) in Middle income in 2003 to that in 2007?
Your answer should be very brief. 1.1. What is the ratio of the Expenses (% of total expenses) in Bangladesh in 2003 to that in 2007?
Offer a terse response. 1.02. What is the ratio of the Expenses (% of total expenses) in Trinidad and Tobago in 2003 to that in 2007?
Offer a terse response. 1.41. What is the ratio of the Expenses (% of total expenses) of High income in 2003 to that in 2008?
Your answer should be very brief. 0.9. What is the ratio of the Expenses (% of total expenses) of Middle income in 2003 to that in 2008?
Ensure brevity in your answer.  1.05. What is the ratio of the Expenses (% of total expenses) of Bangladesh in 2003 to that in 2008?
Provide a succinct answer. 1.23. What is the ratio of the Expenses (% of total expenses) of Trinidad and Tobago in 2003 to that in 2008?
Provide a short and direct response. 1.72. What is the ratio of the Expenses (% of total expenses) of High income in 2003 to that in 2009?
Give a very brief answer. 0.97. What is the ratio of the Expenses (% of total expenses) of Middle income in 2003 to that in 2009?
Your response must be concise. 1.02. What is the ratio of the Expenses (% of total expenses) in Bangladesh in 2003 to that in 2009?
Your response must be concise. 1.34. What is the ratio of the Expenses (% of total expenses) of Trinidad and Tobago in 2003 to that in 2009?
Your response must be concise. 1.45. What is the ratio of the Expenses (% of total expenses) of High income in 2003 to that in 2010?
Provide a short and direct response. 1.05. What is the ratio of the Expenses (% of total expenses) of Middle income in 2003 to that in 2010?
Your response must be concise. 1.04. What is the ratio of the Expenses (% of total expenses) in Bangladesh in 2003 to that in 2010?
Make the answer very short. 1.19. What is the ratio of the Expenses (% of total expenses) of Trinidad and Tobago in 2003 to that in 2010?
Your response must be concise. 1.53. What is the ratio of the Expenses (% of total expenses) in High income in 2004 to that in 2005?
Keep it short and to the point. 1. What is the ratio of the Expenses (% of total expenses) in Bangladesh in 2004 to that in 2005?
Offer a very short reply. 1.1. What is the ratio of the Expenses (% of total expenses) of Trinidad and Tobago in 2004 to that in 2005?
Give a very brief answer. 1.05. What is the ratio of the Expenses (% of total expenses) of High income in 2004 to that in 2006?
Your response must be concise. 1. What is the ratio of the Expenses (% of total expenses) in Middle income in 2004 to that in 2006?
Offer a terse response. 1.01. What is the ratio of the Expenses (% of total expenses) of Bangladesh in 2004 to that in 2006?
Offer a very short reply. 1.07. What is the ratio of the Expenses (% of total expenses) of Trinidad and Tobago in 2004 to that in 2006?
Your answer should be compact. 1.52. What is the ratio of the Expenses (% of total expenses) of High income in 2004 to that in 2007?
Keep it short and to the point. 0.92. What is the ratio of the Expenses (% of total expenses) of Middle income in 2004 to that in 2007?
Provide a succinct answer. 1.04. What is the ratio of the Expenses (% of total expenses) of Bangladesh in 2004 to that in 2007?
Provide a short and direct response. 1.03. What is the ratio of the Expenses (% of total expenses) in Trinidad and Tobago in 2004 to that in 2007?
Provide a succinct answer. 1.26. What is the ratio of the Expenses (% of total expenses) in High income in 2004 to that in 2008?
Give a very brief answer. 0.92. What is the ratio of the Expenses (% of total expenses) in Middle income in 2004 to that in 2008?
Make the answer very short. 0.99. What is the ratio of the Expenses (% of total expenses) in Bangladesh in 2004 to that in 2008?
Your answer should be very brief. 1.24. What is the ratio of the Expenses (% of total expenses) of Trinidad and Tobago in 2004 to that in 2008?
Make the answer very short. 1.53. What is the ratio of the Expenses (% of total expenses) in High income in 2004 to that in 2009?
Ensure brevity in your answer.  0.99. What is the ratio of the Expenses (% of total expenses) in Middle income in 2004 to that in 2009?
Give a very brief answer. 0.97. What is the ratio of the Expenses (% of total expenses) of Bangladesh in 2004 to that in 2009?
Make the answer very short. 1.35. What is the ratio of the Expenses (% of total expenses) in Trinidad and Tobago in 2004 to that in 2009?
Give a very brief answer. 1.29. What is the ratio of the Expenses (% of total expenses) in High income in 2004 to that in 2010?
Provide a short and direct response. 1.08. What is the ratio of the Expenses (% of total expenses) in Middle income in 2004 to that in 2010?
Keep it short and to the point. 0.98. What is the ratio of the Expenses (% of total expenses) of Bangladesh in 2004 to that in 2010?
Provide a short and direct response. 1.2. What is the ratio of the Expenses (% of total expenses) in Trinidad and Tobago in 2004 to that in 2010?
Your answer should be very brief. 1.37. What is the ratio of the Expenses (% of total expenses) in High income in 2005 to that in 2006?
Your answer should be compact. 1. What is the ratio of the Expenses (% of total expenses) in Bangladesh in 2005 to that in 2006?
Offer a very short reply. 0.98. What is the ratio of the Expenses (% of total expenses) of Trinidad and Tobago in 2005 to that in 2006?
Make the answer very short. 1.45. What is the ratio of the Expenses (% of total expenses) in High income in 2005 to that in 2007?
Your response must be concise. 0.92. What is the ratio of the Expenses (% of total expenses) in Middle income in 2005 to that in 2007?
Your answer should be very brief. 1.03. What is the ratio of the Expenses (% of total expenses) of Bangladesh in 2005 to that in 2007?
Provide a succinct answer. 0.93. What is the ratio of the Expenses (% of total expenses) in Trinidad and Tobago in 2005 to that in 2007?
Give a very brief answer. 1.2. What is the ratio of the Expenses (% of total expenses) of High income in 2005 to that in 2008?
Your response must be concise. 0.92. What is the ratio of the Expenses (% of total expenses) in Middle income in 2005 to that in 2008?
Make the answer very short. 0.98. What is the ratio of the Expenses (% of total expenses) in Bangladesh in 2005 to that in 2008?
Make the answer very short. 1.13. What is the ratio of the Expenses (% of total expenses) of Trinidad and Tobago in 2005 to that in 2008?
Keep it short and to the point. 1.46. What is the ratio of the Expenses (% of total expenses) in High income in 2005 to that in 2009?
Give a very brief answer. 0.99. What is the ratio of the Expenses (% of total expenses) in Middle income in 2005 to that in 2009?
Keep it short and to the point. 0.96. What is the ratio of the Expenses (% of total expenses) of Bangladesh in 2005 to that in 2009?
Give a very brief answer. 1.23. What is the ratio of the Expenses (% of total expenses) in Trinidad and Tobago in 2005 to that in 2009?
Your answer should be very brief. 1.23. What is the ratio of the Expenses (% of total expenses) in High income in 2005 to that in 2010?
Keep it short and to the point. 1.08. What is the ratio of the Expenses (% of total expenses) in Middle income in 2005 to that in 2010?
Keep it short and to the point. 0.97. What is the ratio of the Expenses (% of total expenses) of Bangladesh in 2005 to that in 2010?
Your answer should be compact. 1.09. What is the ratio of the Expenses (% of total expenses) of Trinidad and Tobago in 2005 to that in 2010?
Provide a short and direct response. 1.31. What is the ratio of the Expenses (% of total expenses) in High income in 2006 to that in 2007?
Give a very brief answer. 0.92. What is the ratio of the Expenses (% of total expenses) in Middle income in 2006 to that in 2007?
Keep it short and to the point. 1.03. What is the ratio of the Expenses (% of total expenses) of Bangladesh in 2006 to that in 2007?
Give a very brief answer. 0.96. What is the ratio of the Expenses (% of total expenses) of Trinidad and Tobago in 2006 to that in 2007?
Provide a short and direct response. 0.83. What is the ratio of the Expenses (% of total expenses) of High income in 2006 to that in 2008?
Offer a terse response. 0.92. What is the ratio of the Expenses (% of total expenses) in Middle income in 2006 to that in 2008?
Keep it short and to the point. 0.98. What is the ratio of the Expenses (% of total expenses) of Bangladesh in 2006 to that in 2008?
Your answer should be very brief. 1.16. What is the ratio of the Expenses (% of total expenses) of Trinidad and Tobago in 2006 to that in 2008?
Keep it short and to the point. 1.01. What is the ratio of the Expenses (% of total expenses) of Middle income in 2006 to that in 2009?
Make the answer very short. 0.96. What is the ratio of the Expenses (% of total expenses) of Bangladesh in 2006 to that in 2009?
Make the answer very short. 1.26. What is the ratio of the Expenses (% of total expenses) in High income in 2006 to that in 2010?
Provide a succinct answer. 1.08. What is the ratio of the Expenses (% of total expenses) in Middle income in 2006 to that in 2010?
Provide a short and direct response. 0.97. What is the ratio of the Expenses (% of total expenses) in Bangladesh in 2006 to that in 2010?
Offer a terse response. 1.12. What is the ratio of the Expenses (% of total expenses) in Trinidad and Tobago in 2006 to that in 2010?
Your answer should be compact. 0.9. What is the ratio of the Expenses (% of total expenses) in Middle income in 2007 to that in 2008?
Give a very brief answer. 0.95. What is the ratio of the Expenses (% of total expenses) in Bangladesh in 2007 to that in 2008?
Your answer should be compact. 1.21. What is the ratio of the Expenses (% of total expenses) in Trinidad and Tobago in 2007 to that in 2008?
Keep it short and to the point. 1.22. What is the ratio of the Expenses (% of total expenses) in High income in 2007 to that in 2009?
Provide a short and direct response. 1.08. What is the ratio of the Expenses (% of total expenses) of Middle income in 2007 to that in 2009?
Make the answer very short. 0.93. What is the ratio of the Expenses (% of total expenses) of Bangladesh in 2007 to that in 2009?
Your answer should be very brief. 1.31. What is the ratio of the Expenses (% of total expenses) of Trinidad and Tobago in 2007 to that in 2009?
Give a very brief answer. 1.03. What is the ratio of the Expenses (% of total expenses) of High income in 2007 to that in 2010?
Keep it short and to the point. 1.17. What is the ratio of the Expenses (% of total expenses) in Middle income in 2007 to that in 2010?
Provide a succinct answer. 0.94. What is the ratio of the Expenses (% of total expenses) in Bangladesh in 2007 to that in 2010?
Offer a terse response. 1.17. What is the ratio of the Expenses (% of total expenses) in Trinidad and Tobago in 2007 to that in 2010?
Your answer should be very brief. 1.09. What is the ratio of the Expenses (% of total expenses) of High income in 2008 to that in 2009?
Your answer should be very brief. 1.08. What is the ratio of the Expenses (% of total expenses) of Middle income in 2008 to that in 2009?
Provide a short and direct response. 0.98. What is the ratio of the Expenses (% of total expenses) in Bangladesh in 2008 to that in 2009?
Offer a very short reply. 1.09. What is the ratio of the Expenses (% of total expenses) of Trinidad and Tobago in 2008 to that in 2009?
Your answer should be very brief. 0.84. What is the ratio of the Expenses (% of total expenses) of High income in 2008 to that in 2010?
Your response must be concise. 1.17. What is the ratio of the Expenses (% of total expenses) in Middle income in 2008 to that in 2010?
Your answer should be compact. 0.99. What is the ratio of the Expenses (% of total expenses) of Bangladesh in 2008 to that in 2010?
Give a very brief answer. 0.97. What is the ratio of the Expenses (% of total expenses) in Trinidad and Tobago in 2008 to that in 2010?
Your response must be concise. 0.89. What is the ratio of the Expenses (% of total expenses) of High income in 2009 to that in 2010?
Give a very brief answer. 1.09. What is the ratio of the Expenses (% of total expenses) in Middle income in 2009 to that in 2010?
Offer a very short reply. 1.01. What is the ratio of the Expenses (% of total expenses) in Bangladesh in 2009 to that in 2010?
Ensure brevity in your answer.  0.89. What is the ratio of the Expenses (% of total expenses) of Trinidad and Tobago in 2009 to that in 2010?
Offer a terse response. 1.06. What is the difference between the highest and the second highest Expenses (% of total expenses) of High income?
Your answer should be compact. 0.03. What is the difference between the highest and the second highest Expenses (% of total expenses) of Middle income?
Your answer should be very brief. 0.7. What is the difference between the highest and the second highest Expenses (% of total expenses) of Bangladesh?
Your answer should be very brief. 0.16. What is the difference between the highest and the second highest Expenses (% of total expenses) of Trinidad and Tobago?
Keep it short and to the point. 3.98. What is the difference between the highest and the lowest Expenses (% of total expenses) in High income?
Your answer should be very brief. 2.6. What is the difference between the highest and the lowest Expenses (% of total expenses) of Middle income?
Offer a terse response. 2.7. What is the difference between the highest and the lowest Expenses (% of total expenses) in Bangladesh?
Offer a terse response. 6.57. What is the difference between the highest and the lowest Expenses (% of total expenses) of Trinidad and Tobago?
Your answer should be compact. 15.46. 